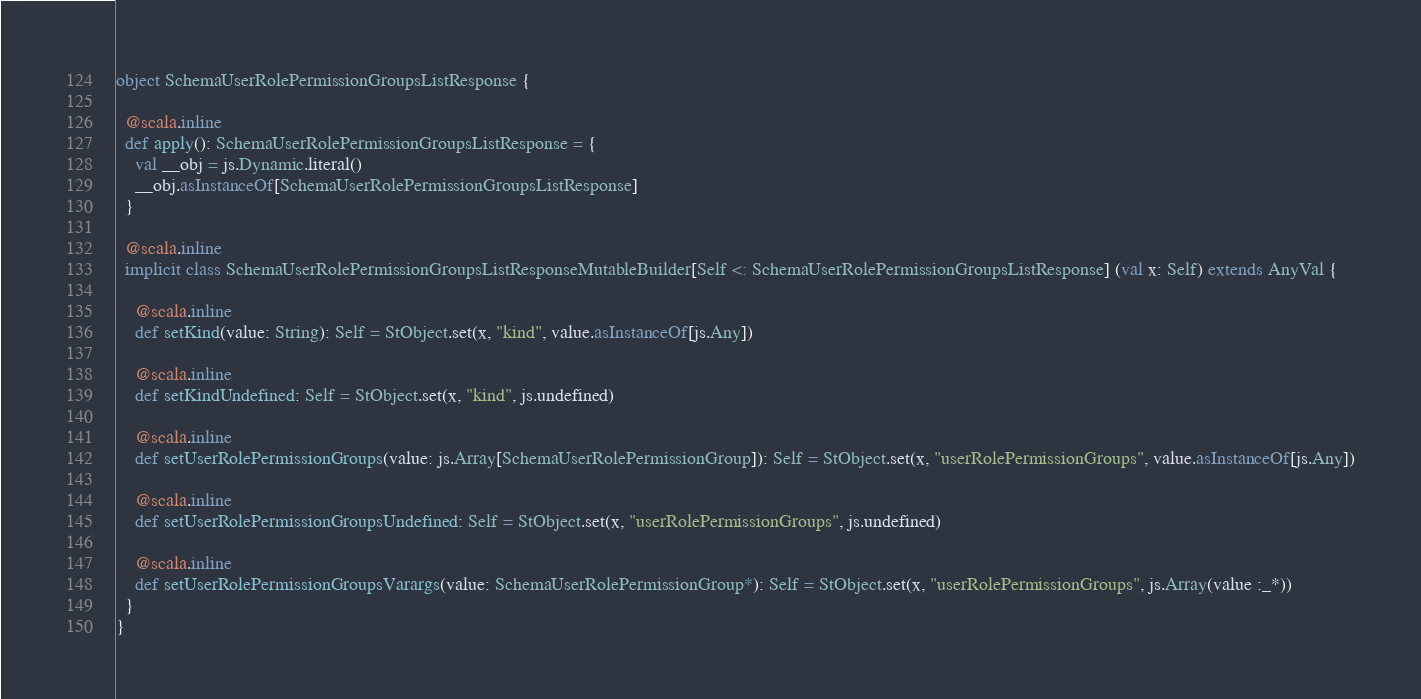<code> <loc_0><loc_0><loc_500><loc_500><_Scala_>object SchemaUserRolePermissionGroupsListResponse {
  
  @scala.inline
  def apply(): SchemaUserRolePermissionGroupsListResponse = {
    val __obj = js.Dynamic.literal()
    __obj.asInstanceOf[SchemaUserRolePermissionGroupsListResponse]
  }
  
  @scala.inline
  implicit class SchemaUserRolePermissionGroupsListResponseMutableBuilder[Self <: SchemaUserRolePermissionGroupsListResponse] (val x: Self) extends AnyVal {
    
    @scala.inline
    def setKind(value: String): Self = StObject.set(x, "kind", value.asInstanceOf[js.Any])
    
    @scala.inline
    def setKindUndefined: Self = StObject.set(x, "kind", js.undefined)
    
    @scala.inline
    def setUserRolePermissionGroups(value: js.Array[SchemaUserRolePermissionGroup]): Self = StObject.set(x, "userRolePermissionGroups", value.asInstanceOf[js.Any])
    
    @scala.inline
    def setUserRolePermissionGroupsUndefined: Self = StObject.set(x, "userRolePermissionGroups", js.undefined)
    
    @scala.inline
    def setUserRolePermissionGroupsVarargs(value: SchemaUserRolePermissionGroup*): Self = StObject.set(x, "userRolePermissionGroups", js.Array(value :_*))
  }
}
</code> 